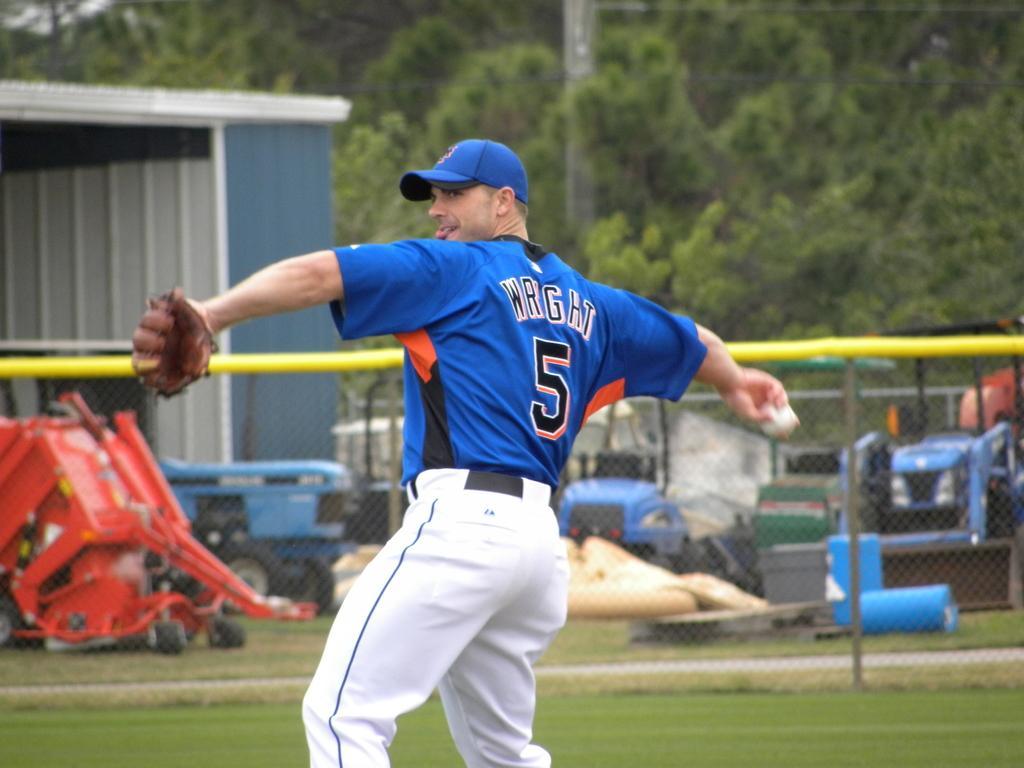In one or two sentences, can you explain what this image depicts? In this image we can see many trees and vehicles. A person is holding a ball. There is a shed at the right side of the image. 